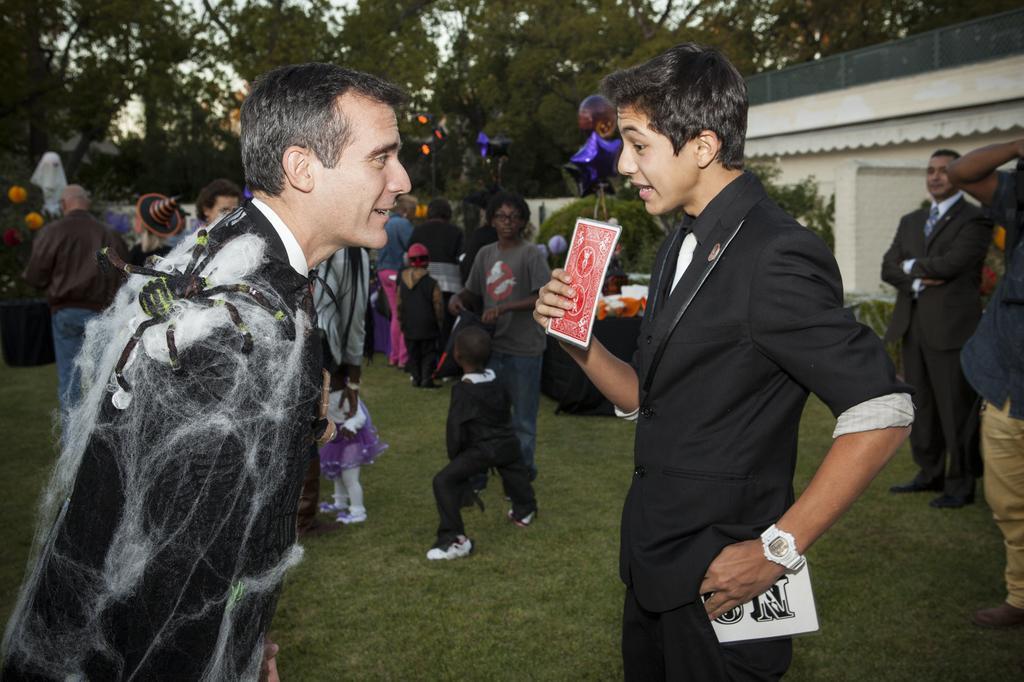Can you describe this image briefly? In this picture there is a boy who is standing on the right side of the image, by holding a card in his hand and there is a man on the left side of the image, there is a spider on his shoulder and there are other people those who are standing on the grassland in the background area of the image and there are trees at the top side of the image, there is a house on the right side of the image. 